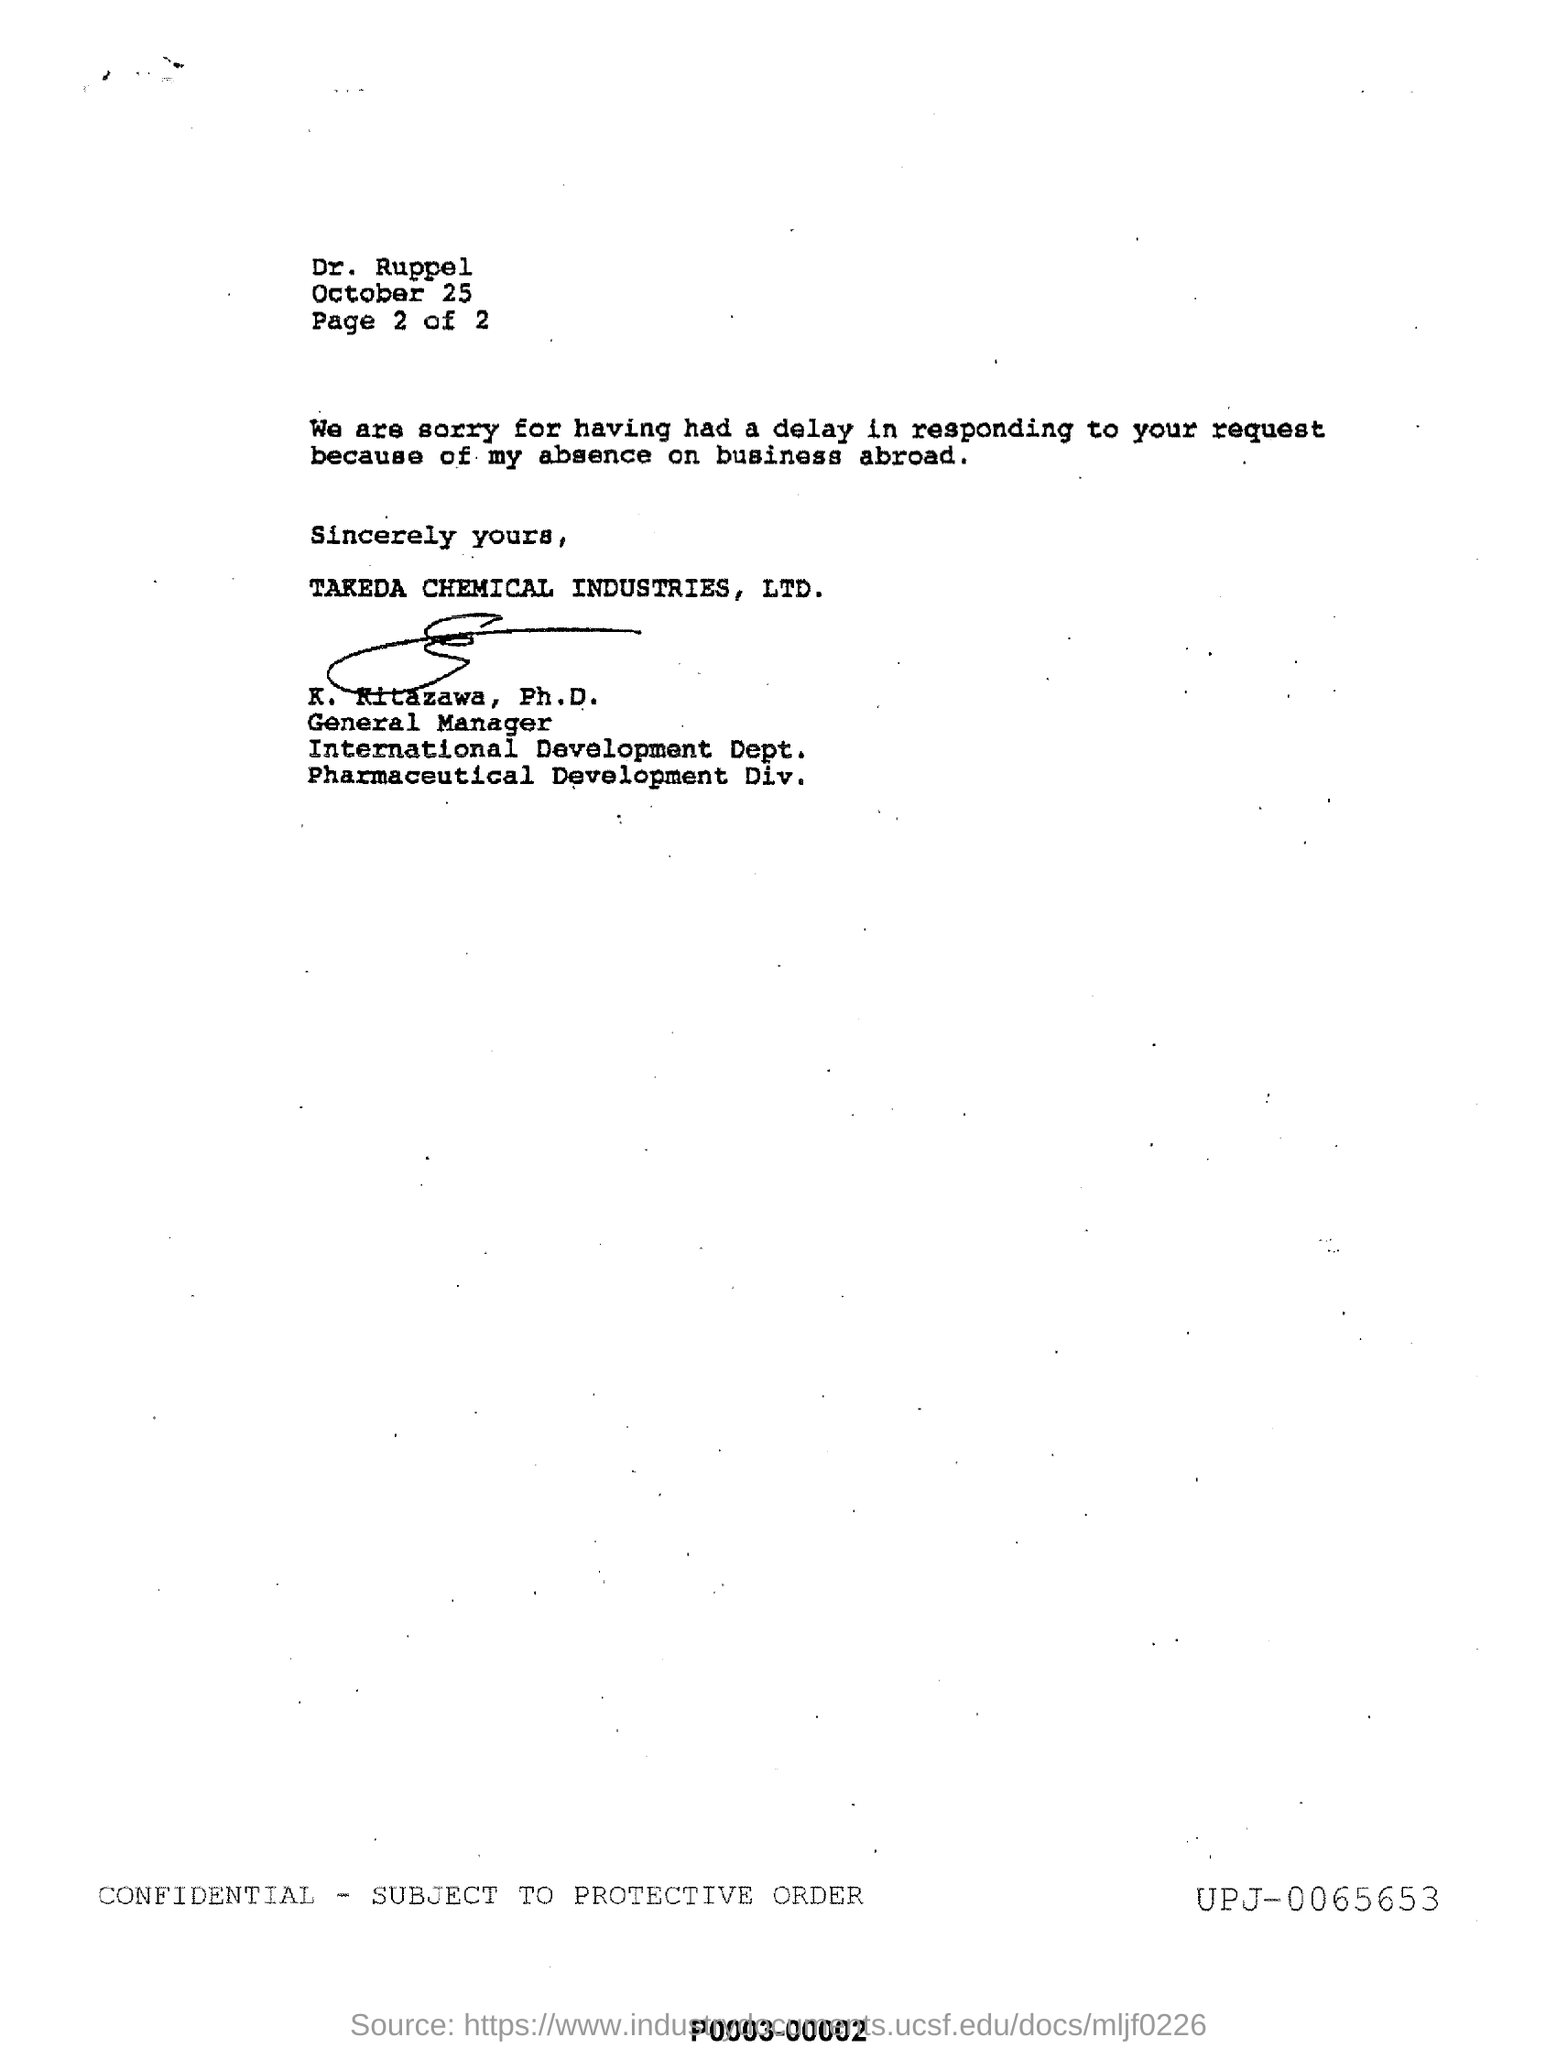Mention a couple of crucial points in this snapshot. The general manager of the International Development Department of Takeda Chemical Industries, Ltd. is K. Kitazawa, who holds a Ph.D. There are 2 pages in total. Takeda Chemical Industries, Ltd. is a company that belongs to the industry. The month and date mentioned in this letter at the top are October 25. 